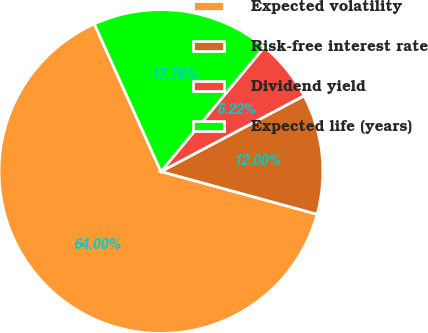Convert chart. <chart><loc_0><loc_0><loc_500><loc_500><pie_chart><fcel>Expected volatility<fcel>Risk-free interest rate<fcel>Dividend yield<fcel>Expected life (years)<nl><fcel>64.01%<fcel>12.0%<fcel>6.22%<fcel>17.78%<nl></chart> 